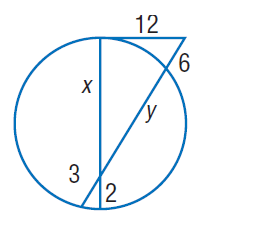Answer the mathemtical geometry problem and directly provide the correct option letter.
Question: Find y. Round to the nearest tenth, if necessary.
Choices: A: 2 B: 3 C: 6 D: 22.5 D 